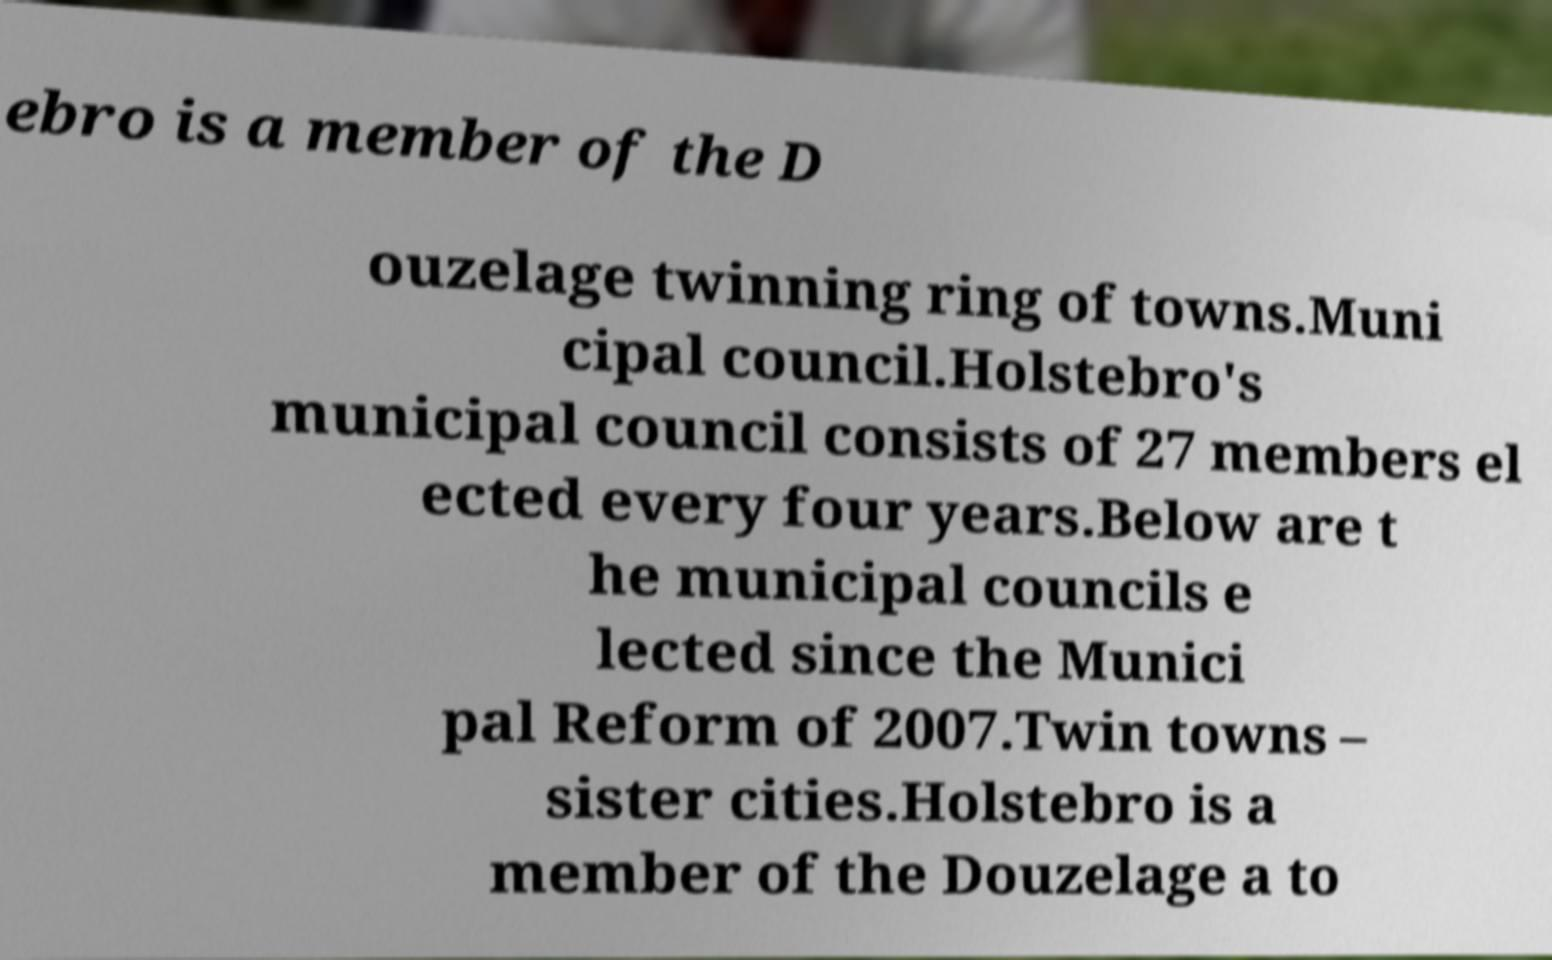Please read and relay the text visible in this image. What does it say? ebro is a member of the D ouzelage twinning ring of towns.Muni cipal council.Holstebro's municipal council consists of 27 members el ected every four years.Below are t he municipal councils e lected since the Munici pal Reform of 2007.Twin towns – sister cities.Holstebro is a member of the Douzelage a to 